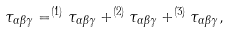<formula> <loc_0><loc_0><loc_500><loc_500>\tau _ { \alpha \beta \gamma } = ^ { ( 1 ) } \tau _ { \alpha \beta \gamma } + ^ { ( 2 ) } \tau _ { \alpha \beta \gamma } + ^ { ( 3 ) } \tau _ { \alpha \beta \gamma } ,</formula> 